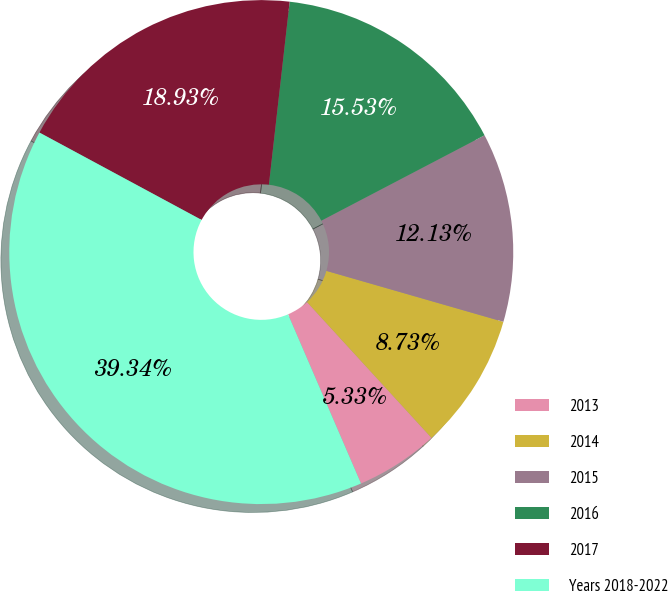Convert chart to OTSL. <chart><loc_0><loc_0><loc_500><loc_500><pie_chart><fcel>2013<fcel>2014<fcel>2015<fcel>2016<fcel>2017<fcel>Years 2018-2022<nl><fcel>5.33%<fcel>8.73%<fcel>12.13%<fcel>15.53%<fcel>18.93%<fcel>39.34%<nl></chart> 